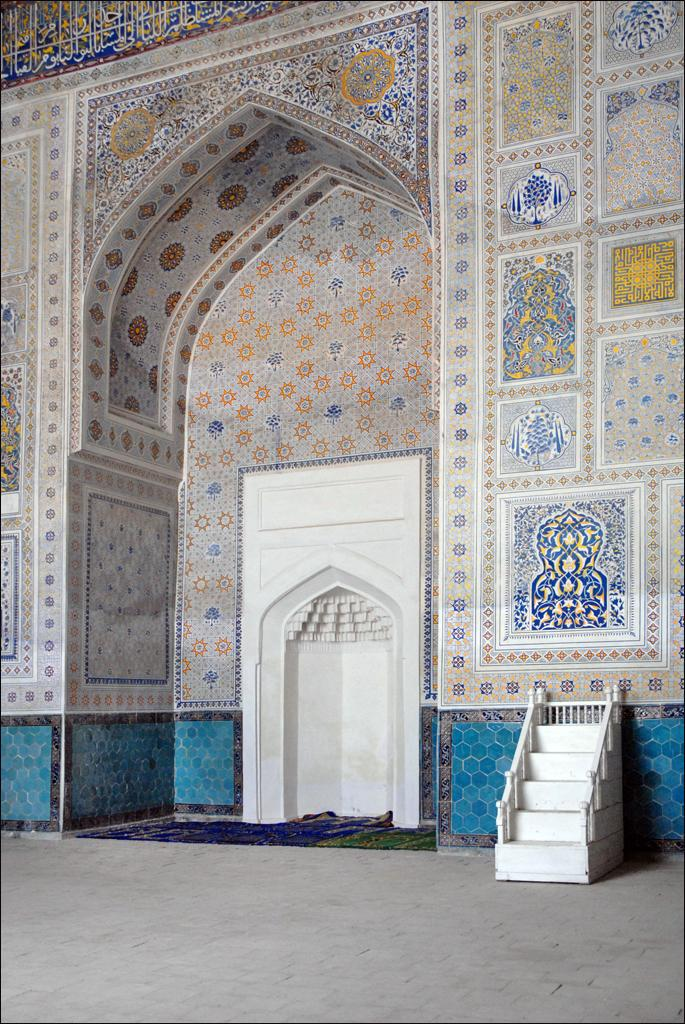What type of structure is present in the image? There is an arch in the image. What can be seen on the right side of the image? There are stars on the right side of the image. What kind of decorations are present in the image? There are wall designs in the image. What type of feather is used to create the wall designs in the image? There is no mention of feathers being used to create the wall designs in the image. The wall designs are likely created using paint, wallpaper, or other materials. 